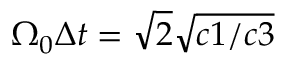<formula> <loc_0><loc_0><loc_500><loc_500>\Omega _ { 0 } \Delta { t } = \sqrt { 2 } \sqrt { c 1 / c 3 }</formula> 